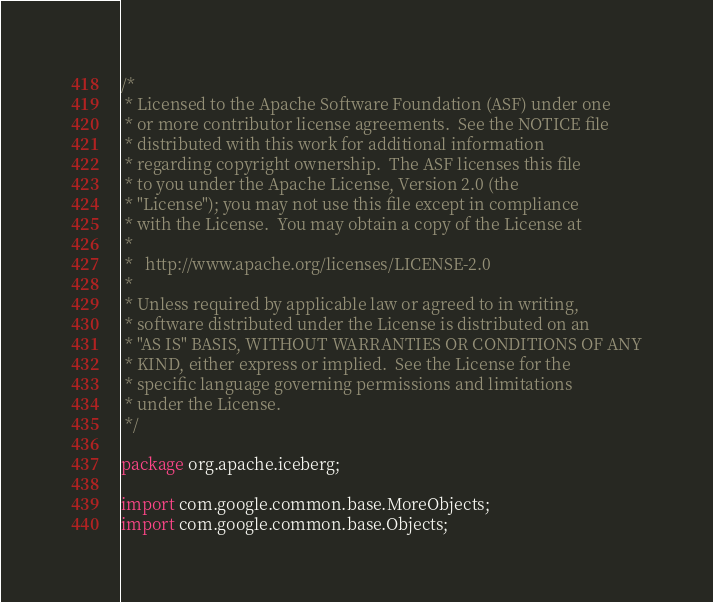Convert code to text. <code><loc_0><loc_0><loc_500><loc_500><_Java_>/*
 * Licensed to the Apache Software Foundation (ASF) under one
 * or more contributor license agreements.  See the NOTICE file
 * distributed with this work for additional information
 * regarding copyright ownership.  The ASF licenses this file
 * to you under the Apache License, Version 2.0 (the
 * "License"); you may not use this file except in compliance
 * with the License.  You may obtain a copy of the License at
 *
 *   http://www.apache.org/licenses/LICENSE-2.0
 *
 * Unless required by applicable law or agreed to in writing,
 * software distributed under the License is distributed on an
 * "AS IS" BASIS, WITHOUT WARRANTIES OR CONDITIONS OF ANY
 * KIND, either express or implied.  See the License for the
 * specific language governing permissions and limitations
 * under the License.
 */

package org.apache.iceberg;

import com.google.common.base.MoreObjects;
import com.google.common.base.Objects;</code> 